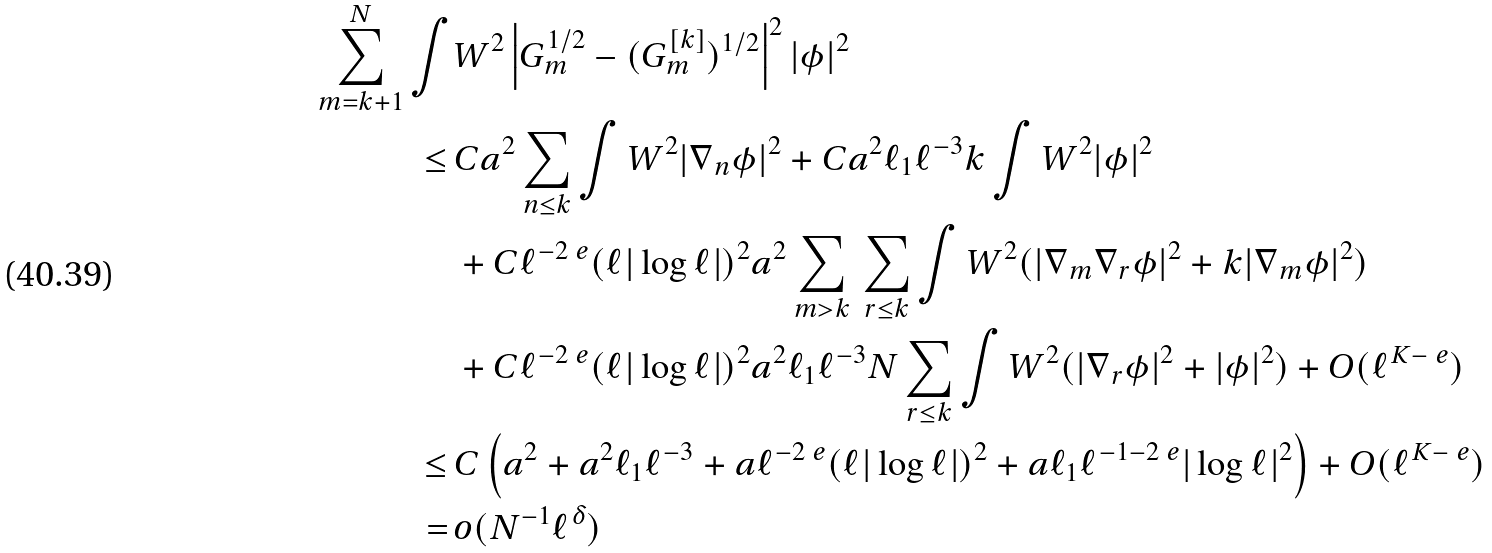Convert formula to latex. <formula><loc_0><loc_0><loc_500><loc_500>\sum _ { m = k + 1 } ^ { N } \int & W ^ { 2 } \left | G _ { m } ^ { 1 / 2 } - ( G _ { m } ^ { [ k ] } ) ^ { 1 / 2 } \right | ^ { 2 } | \phi | ^ { 2 } \\ \leq \, & C a ^ { 2 } \sum _ { n \leq k } \int W ^ { 2 } | \nabla _ { n } \phi | ^ { 2 } + C a ^ { 2 } \ell _ { 1 } \ell ^ { - 3 } k \int W ^ { 2 } | \phi | ^ { 2 } \\ & + C \ell ^ { - 2 \ e } ( \ell | \log \ell | ) ^ { 2 } a ^ { 2 } \sum _ { m > k } \, \sum _ { r \leq k } \int W ^ { 2 } ( | \nabla _ { m } \nabla _ { r } \phi | ^ { 2 } + k | \nabla _ { m } \phi | ^ { 2 } ) \\ & + C \ell ^ { - 2 \ e } ( \ell | \log \ell | ) ^ { 2 } a ^ { 2 } \ell _ { 1 } \ell ^ { - 3 } N \sum _ { r \leq k } \int W ^ { 2 } ( | \nabla _ { r } \phi | ^ { 2 } + | \phi | ^ { 2 } ) + O ( \ell ^ { K - \ e } ) \\ \leq \, & C \left ( a ^ { 2 } + a ^ { 2 } \ell _ { 1 } \ell ^ { - 3 } + a \ell ^ { - 2 \ e } ( \ell | \log \ell | ) ^ { 2 } + a \ell _ { 1 } \ell ^ { - 1 - 2 \ e } | \log \ell | ^ { 2 } \right ) + O ( \ell ^ { K - \ e } ) \\ = \, & o ( N ^ { - 1 } \ell ^ { \delta } )</formula> 